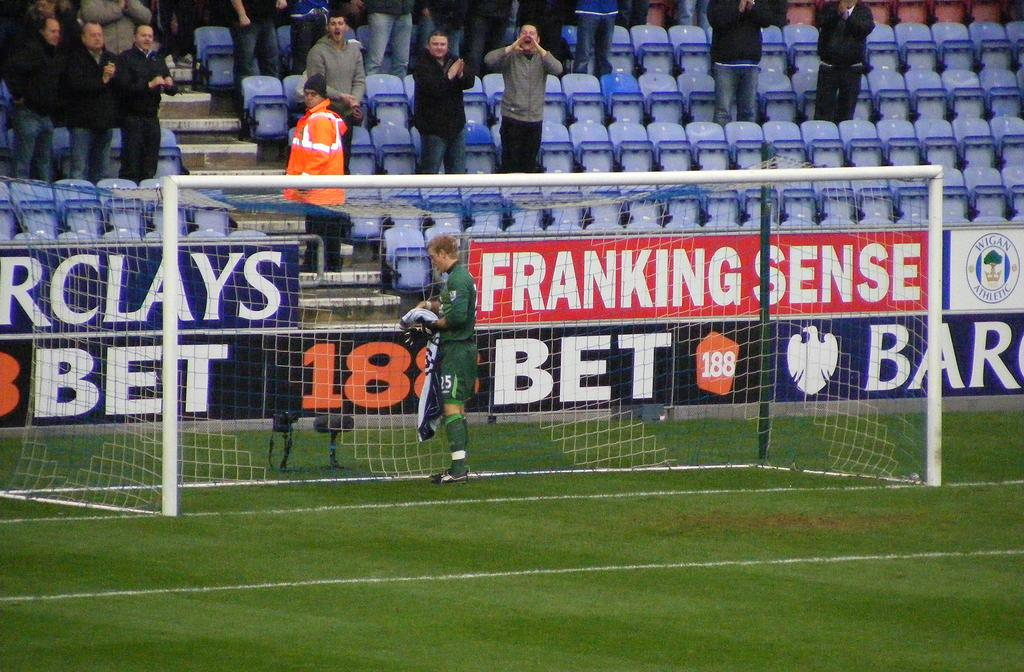<image>
Render a clear and concise summary of the photo. A goal in soccer with granstands behind and an advertisement for Barclay's an english bank 